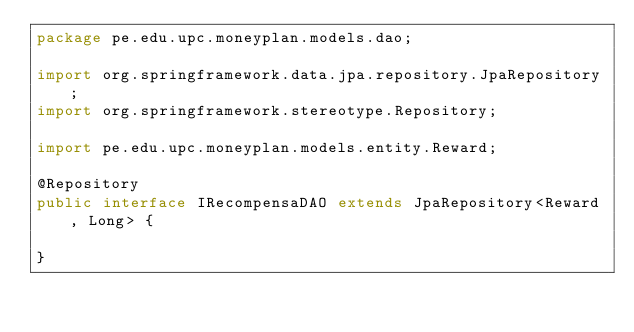<code> <loc_0><loc_0><loc_500><loc_500><_Java_>package pe.edu.upc.moneyplan.models.dao;

import org.springframework.data.jpa.repository.JpaRepository;
import org.springframework.stereotype.Repository;

import pe.edu.upc.moneyplan.models.entity.Reward;

@Repository
public interface IRecompensaDAO extends JpaRepository<Reward, Long> {

}
</code> 